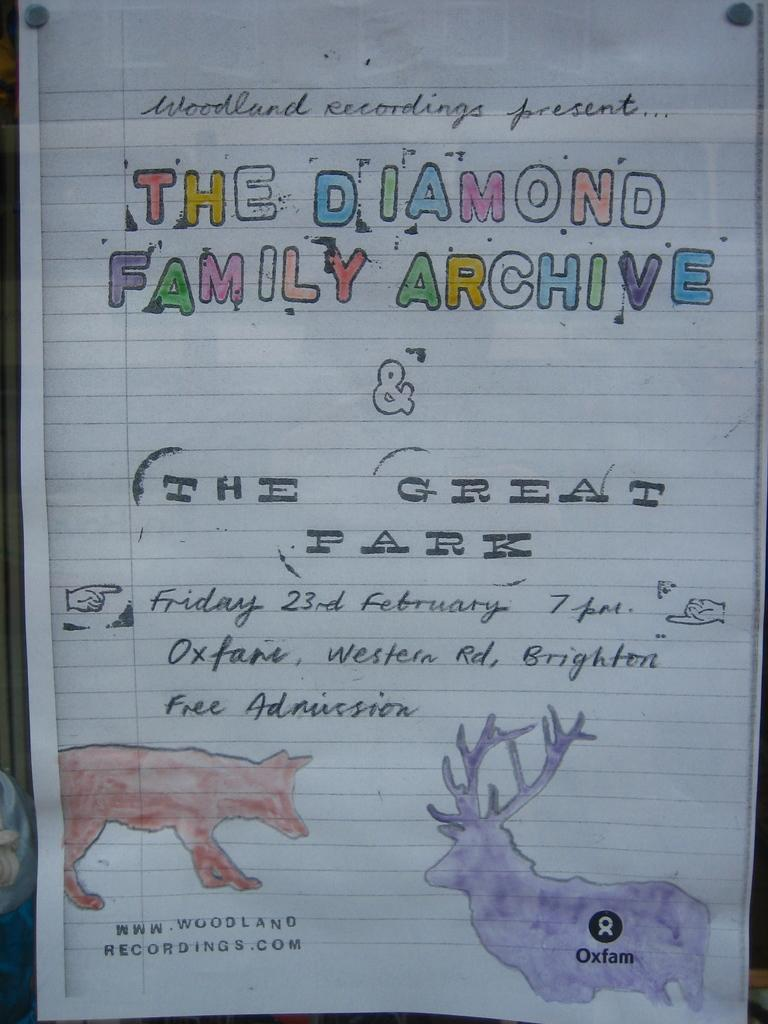What is present on the paper in the image? The paper has text and art on it. Can you describe the content of the paper? The paper has text and art on it, but the specific content cannot be determined from the image alone. What type of insect can be seen crawling on the banana in the image? There is no banana or insect present in the image; it only features a paper with text and art on it. 